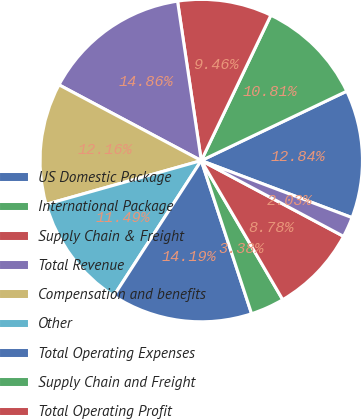Convert chart. <chart><loc_0><loc_0><loc_500><loc_500><pie_chart><fcel>US Domestic Package<fcel>International Package<fcel>Supply Chain & Freight<fcel>Total Revenue<fcel>Compensation and benefits<fcel>Other<fcel>Total Operating Expenses<fcel>Supply Chain and Freight<fcel>Total Operating Profit<fcel>Investment income<nl><fcel>12.84%<fcel>10.81%<fcel>9.46%<fcel>14.86%<fcel>12.16%<fcel>11.49%<fcel>14.19%<fcel>3.38%<fcel>8.78%<fcel>2.03%<nl></chart> 